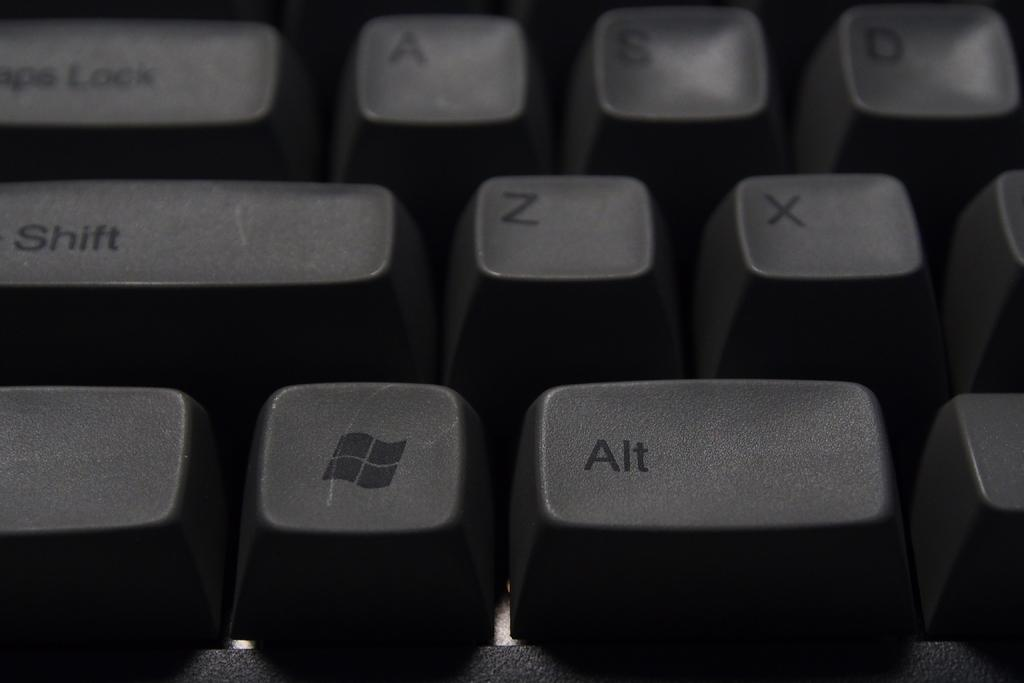<image>
Summarize the visual content of the image. The black keyboard has the Microsoft windows symbol next to the alt key. 